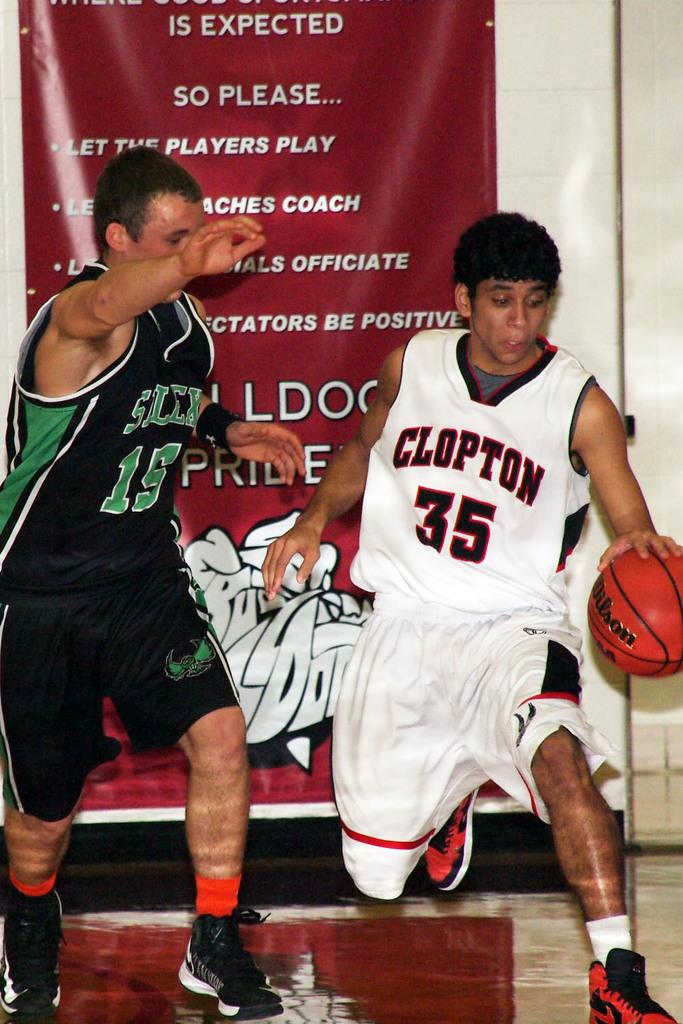Provide a one-sentence caption for the provided image. two basketball players with numbers 35 and 15 on their jerseys. 